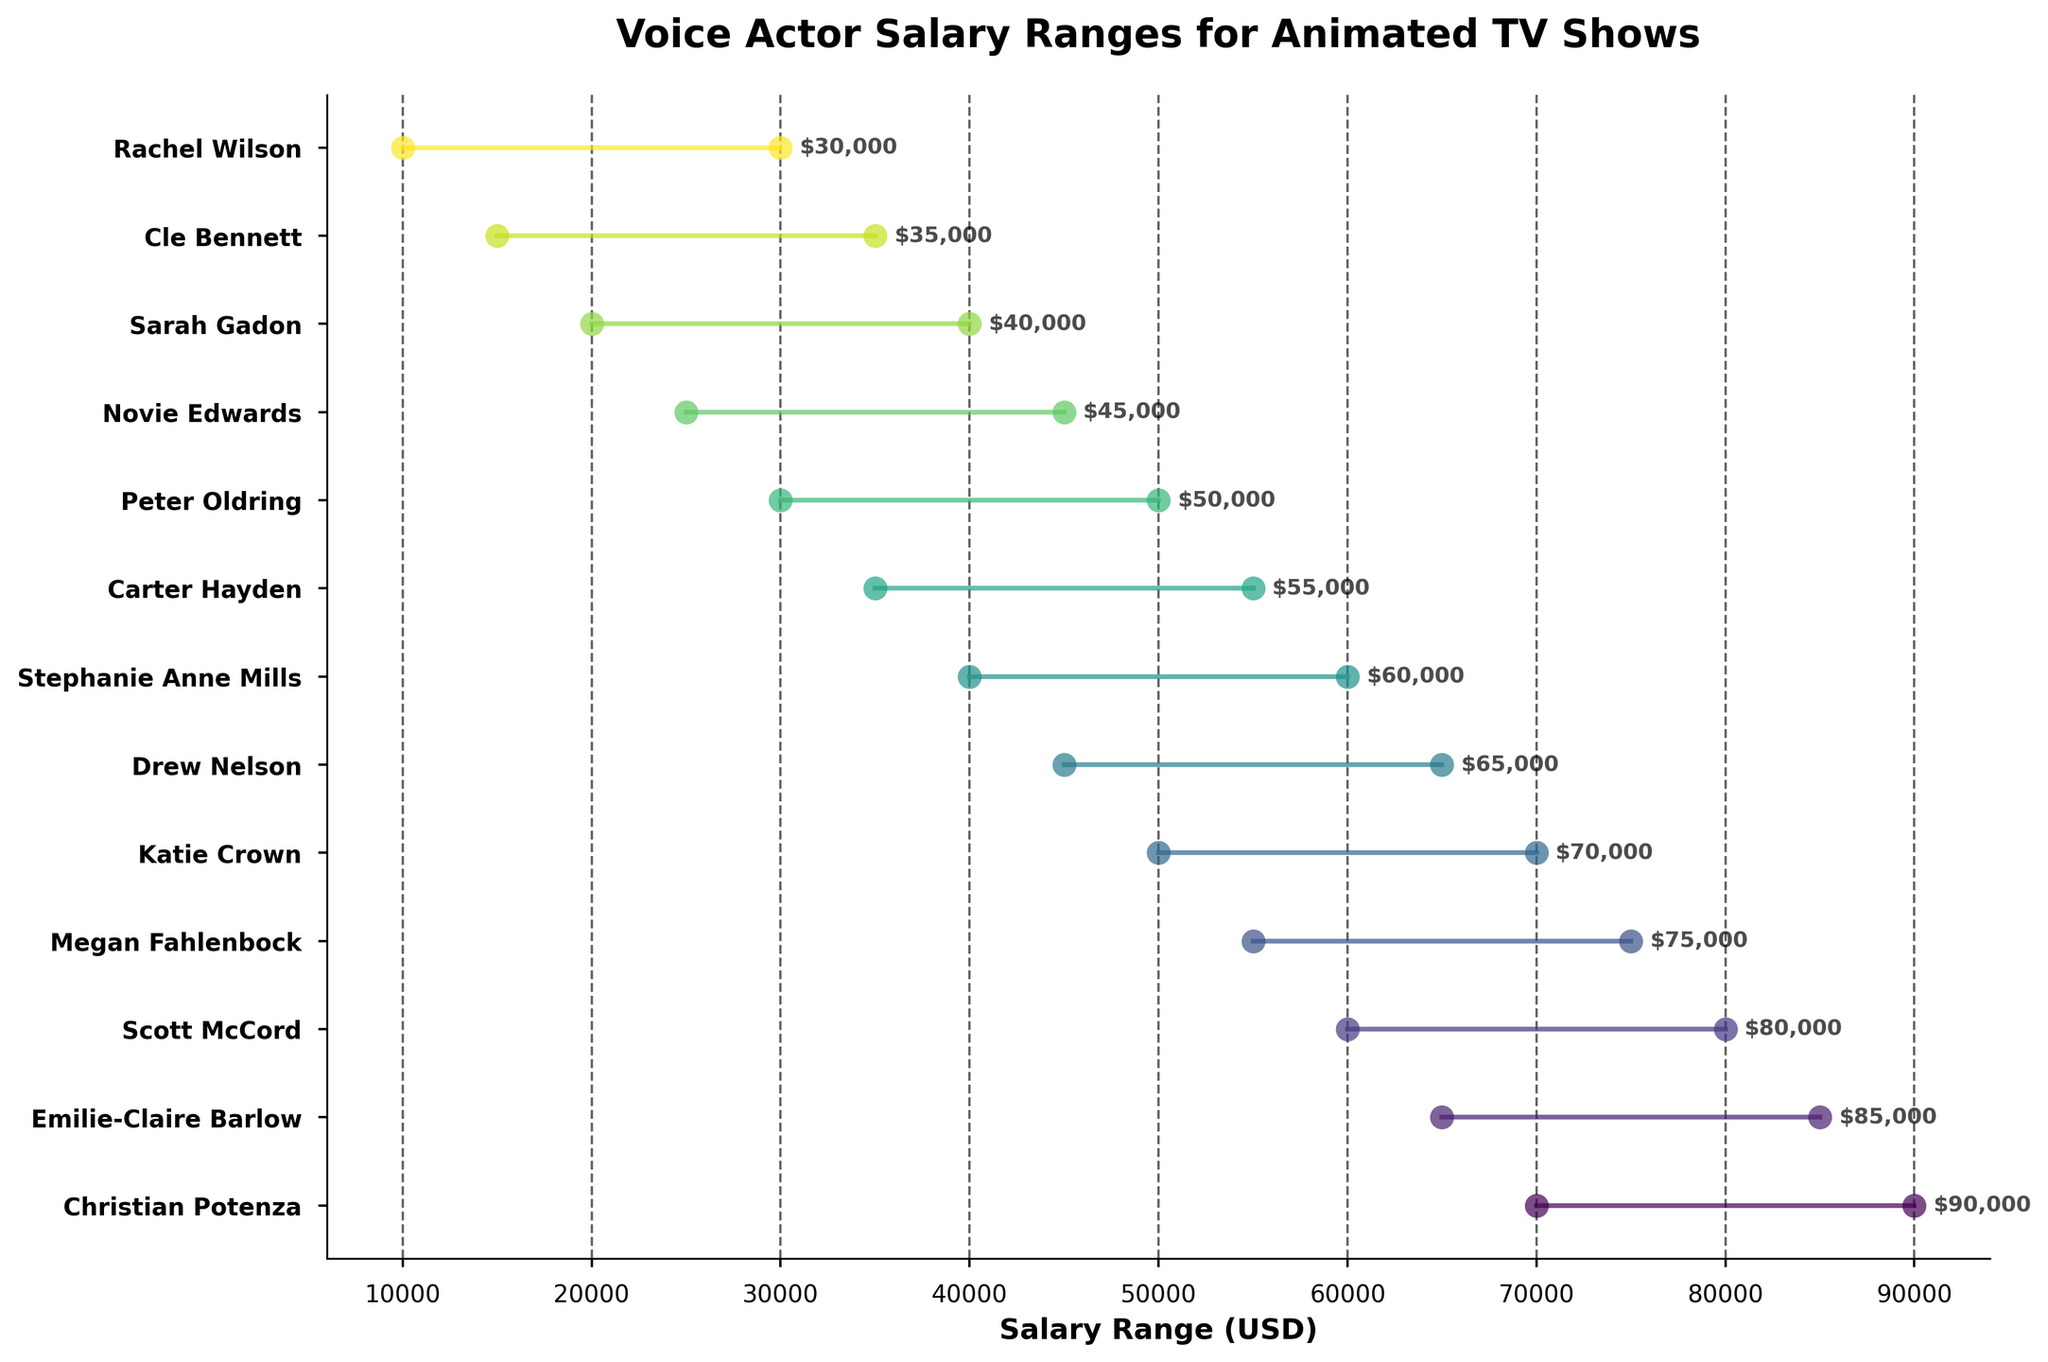What's the title of the plot? The title is usually placed at the top of the plot. In this case, it reads "Voice Actor Salary Ranges for Animated TV Shows".
Answer: Voice Actor Salary Ranges for Animated TV Shows How many voice actors are displayed in the plot? The plot shows 13 different salary ranges, each represented by a distinct line, implying 13 voice actors are displayed.
Answer: 13 Who has the highest maximum salary, and what is it? Check the maximum value at the end of each line in the plot. Christian Potenza has the highest maximum salary. The plot indicates his maximum salary is $90,000.
Answer: Christian Potenza, $90,000 Which voice actor has the lowest minimum salary, and what is it? Look for the smallest starting point (left end) of the salary ranges. Rachel Wilson has the lowest minimum salary which is $10,000.
Answer: Rachel Wilson, $10,000 What is the average maximum salary across all voice actors? Add up all the maximum salaries and divide by the number of voice actors: (90,000 + 85,000 + 80,000 + 75,000 + 70,000 + 65,000 + 60,000 + 55,000 + 50,000 + 45,000 + 40,000 + 35,000 + 30,000) / 13 = 680,000 / 13 ≈ 52,308
Answer: ≈ $52,308 Compare the salary range of Christian Potenza and Stephanie Anne Mills. Who has a wider range and by how much? Calculate the salary range for each actor by subtracting their minimum salary from their maximum salary: Christian Potenza: 90,000 - 70,000 = 20,000; Stephanie Anne Mills: 60,000 - 40,000 = 20,000. Both have the same range of $20,000.
Answer: Both have the same range, $20,000 Who is the voice actor with the most similar maximum salary to Drew Nelson? Drew Nelson's maximum salary is $65,000. Look for the voice actor with the nearest maximum salary. Megan Fahlenbock has a maximum salary of $75,000, which is the most similar.
Answer: Megan Fahlenbock List the voice actors whose maximum salary is greater than $70,000. Identify the actors whose lines end at values greater than $70,000: Christian Potenza, Emilie-Claire Barlow, and Megan Fahlenbock.
Answer: Christian Potenza, Emilie-Claire Barlow, Megan Fahlenbock What is the total combined range of salaries for all voice actors? Calculate the range for each actor (max - min salary) and sum them up: 20,000 + 20,000 + 20,000 + 20,000 + 20,000 + 20,000 + 20,000 + 20,000 + 20,000 + 20,000 + 20,000 + 20,000 + 20,000 = 260,000
Answer: $260,000 What is the difference between the maximum salary of Katie Crown and the minimum salary of Cle Bennett? Katie Crown's maximum salary is $70,000, and Cle Bennett's minimum salary is $15,000. The difference is 70,000 - 15,000 = 55,000.
Answer: $55,000 